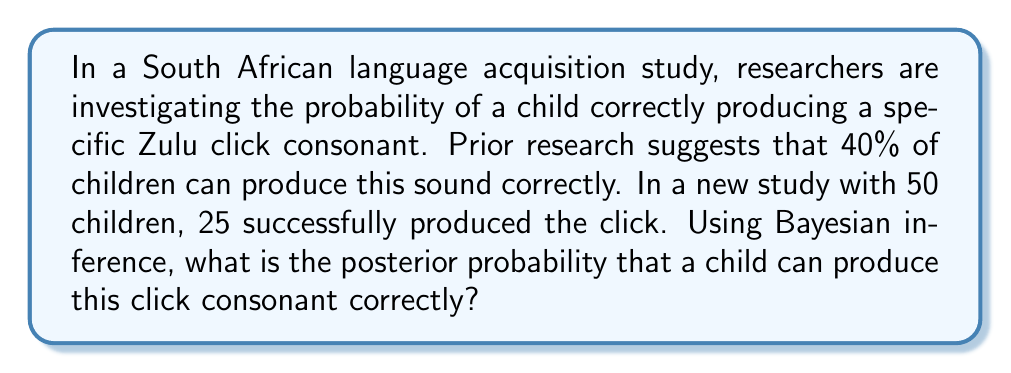Give your solution to this math problem. Let's approach this step-by-step using Bayesian inference:

1) Define our variables:
   $\theta$ = probability of a child producing the click correctly
   $D$ = observed data (25 successes out of 50 trials)

2) We need to calculate $P(\theta|D)$ using Bayes' theorem:

   $$P(\theta|D) = \frac{P(D|\theta) \cdot P(\theta)}{P(D)}$$

3) Prior probability $P(\theta)$:
   Based on prior research, we assume $P(\theta) = 0.4$

4) Likelihood $P(D|\theta)$:
   This follows a binomial distribution:
   $$P(D|\theta) = \binom{50}{25} \theta^{25} (1-\theta)^{25}$$

5) Evidence $P(D)$:
   This is a normalizing constant. We can calculate it as:
   $$P(D) = P(D|\theta=0.4) \cdot P(\theta=0.4) + P(D|\theta\neq0.4) \cdot P(\theta\neq0.4)$$
   $$= \binom{50}{25} 0.4^{25} 0.6^{25} \cdot 0.4 + \binom{50}{25} 0.5^{50} \cdot 0.6$$

6) Now we can calculate the posterior probability:

   $$P(\theta|D) = \frac{\binom{50}{25} 0.4^{25} 0.6^{25} \cdot 0.4}{\binom{50}{25} 0.4^{25} 0.6^{25} \cdot 0.4 + \binom{50}{25} 0.5^{50} \cdot 0.6}$$

7) Simplifying:

   $$P(\theta|D) = \frac{0.4^{26} 0.6^{25}}{0.4^{26} 0.6^{25} + 0.4 \cdot 0.5^{50}}$$

8) Calculating:

   $$P(\theta|D) \approx 0.4934$$

Therefore, the posterior probability that a child can produce this click consonant correctly is approximately 0.4934 or 49.34%.
Answer: 0.4934 